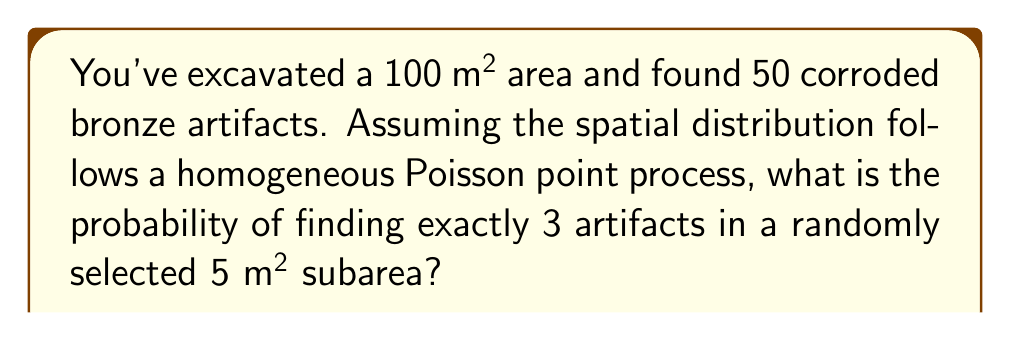Can you solve this math problem? To solve this problem, we'll use the properties of a homogeneous Poisson point process:

1. Calculate the intensity (λ) of the process:
   λ = total artifacts / total area
   λ = 50 / 100 = 0.5 artifacts/m²

2. Determine the expected number of artifacts (μ) in the 5 m² subarea:
   μ = λ * subarea
   μ = 0.5 * 5 = 2.5 artifacts

3. Use the Poisson probability mass function to calculate the probability:
   $$P(X = k) = \frac{e^{-μ} * μ^k}{k!}$$

   Where:
   e ≈ 2.71828 (Euler's number)
   μ = 2.5 (expected number of artifacts)
   k = 3 (desired number of artifacts)

4. Plug in the values:
   $$P(X = 3) = \frac{e^{-2.5} * 2.5^3}{3!}$$

5. Evaluate:
   $$P(X = 3) = \frac{0.082085 * 15.625}{6} ≈ 0.2138$$

6. Convert to a percentage:
   0.2138 * 100 ≈ 21.38%
Answer: 21.38% 